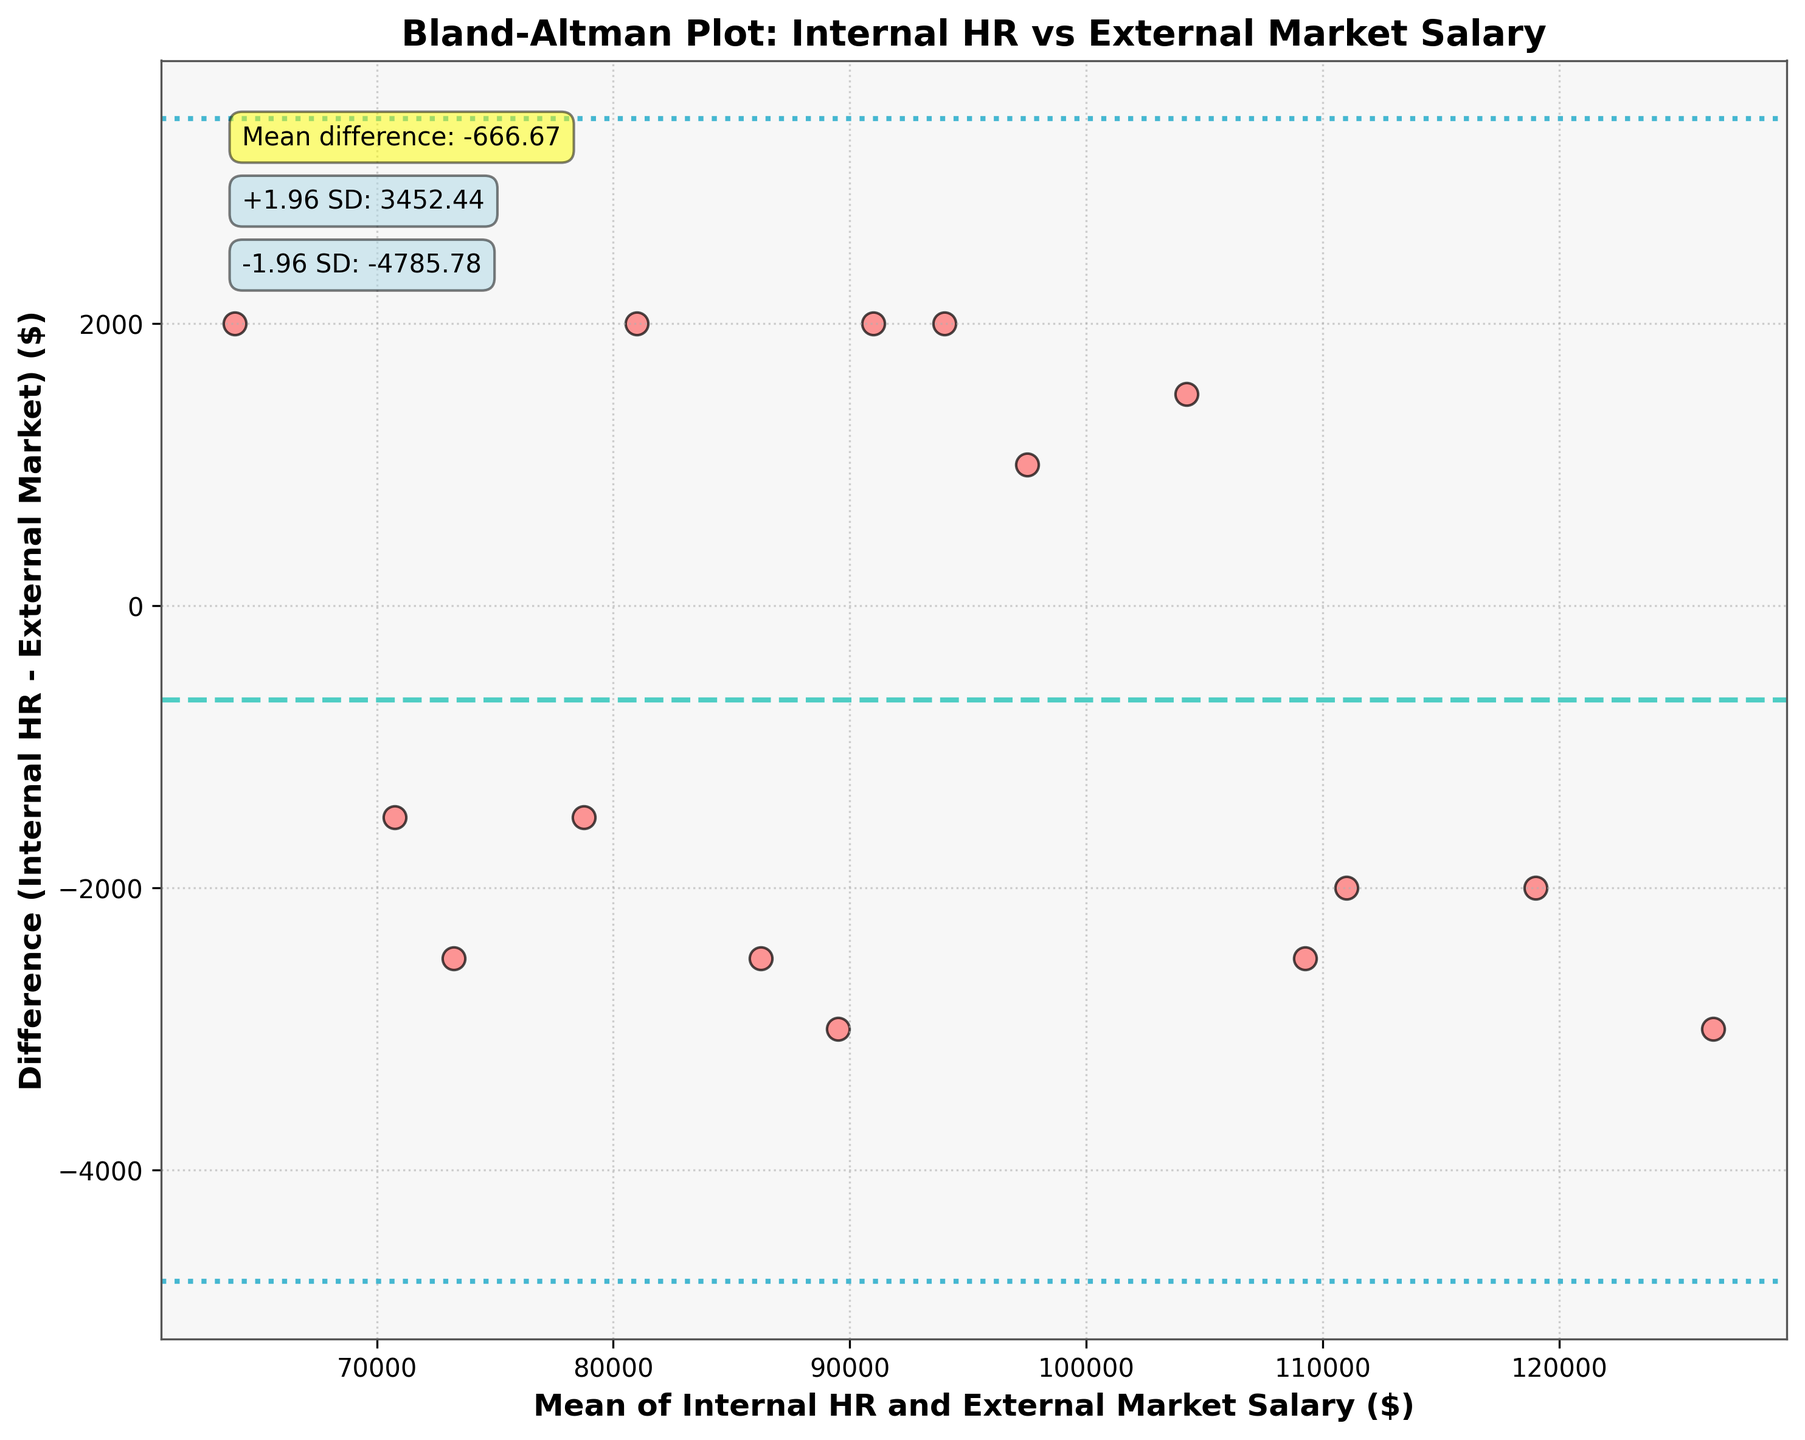What is the title of the plot? The title of the plot can be found at the top of the figure. It reads "Bland-Altman Plot: Internal HR vs External Market Salary".
Answer: Bland-Altman Plot: Internal HR vs External Market Salary How many data points are there in the plot? To find the number of data points, count the scatter points in the figure. Each point represents a salary data comparison between internal HR and external market. There are 15 points.
Answer: 15 What do the dashed and dotted lines represent? The dashed line indicates the mean difference between the internal HR and external market salary, while the dotted lines represent the limits of agreement (+1.96 and -1.96 standard deviations from the mean difference).
Answer: Mean difference and limits of agreement What's the mean difference between internal HR and external market salaries? The mean difference is indicated by the horizontal dashed line on the plot and also annotated as "Mean difference: -466.67".
Answer: -466.67 What are the limits of agreement in the plot? The limits of agreement are shown by the dotted lines and annotated as "+1.96 SD: 4557.97" and "-1.96 SD: -5491.30".
Answer: -5491.30 and 4557.97 Are there any outliers outside the limits of agreement? If yes, how many? By examining the positions of the scatter points relative to the dotted lines, we can see if any points fall outside these limits. There are no points outside the dotted lines, hence no outliers.
Answer: No What's the range of the mean salaries plotted on the x-axis? The x-axis represents the mean of internal HR and external market salaries. We look at the smallest and largest x values of the data points to determine this range. The values range approximately from 65,000 to 126,500.
Answer: 65,000 to 126,500 What's the largest difference between internal HR and external market salaries? To find the largest difference, observe the scatter points and note the highest absolute value on the y-axis. The maximum difference appears to be just below 4,500.
Answer: ~4,500 Is the mean difference positive or negative? The mean difference is annotated on the plot and is a negative value (-466.67), indicating that internal HR salaries are slightly less than external market salaries on average.
Answer: Negative What can you infer if most points are close to the dashed line? If most points are close to the dashed line (mean difference), it indicates good agreement between internal HR and external market salaries since their differences are minimal.
Answer: Good agreement 